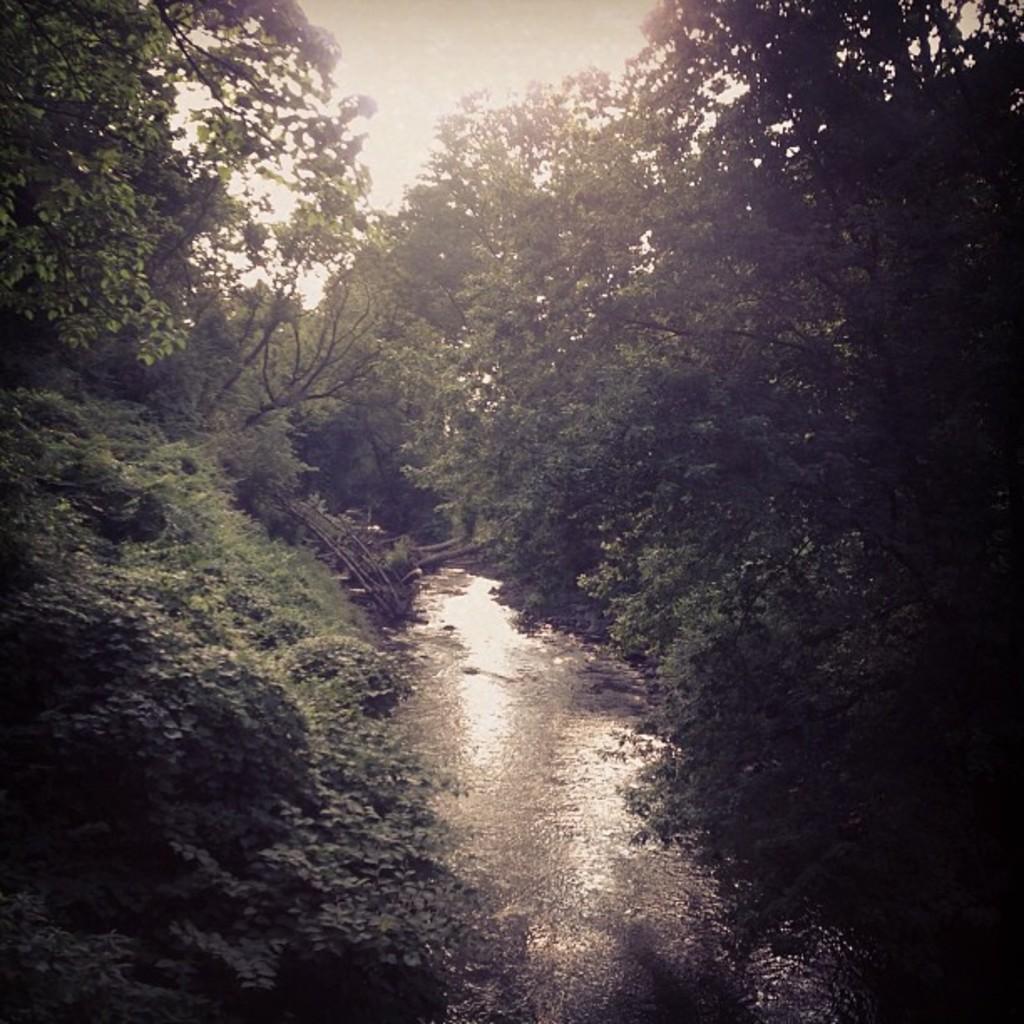Could you give a brief overview of what you see in this image? This looks like a forest. I can see a small canal with the water flowing. These are the trees with branches and leaves. 